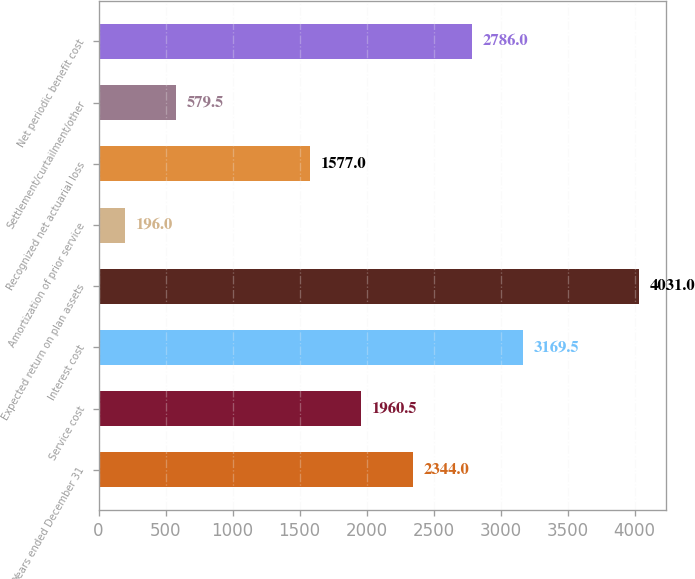Convert chart to OTSL. <chart><loc_0><loc_0><loc_500><loc_500><bar_chart><fcel>Years ended December 31<fcel>Service cost<fcel>Interest cost<fcel>Expected return on plan assets<fcel>Amortization of prior service<fcel>Recognized net actuarial loss<fcel>Settlement/curtailment/other<fcel>Net periodic benefit cost<nl><fcel>2344<fcel>1960.5<fcel>3169.5<fcel>4031<fcel>196<fcel>1577<fcel>579.5<fcel>2786<nl></chart> 